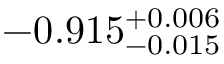Convert formula to latex. <formula><loc_0><loc_0><loc_500><loc_500>- 0 . 9 1 5 _ { - 0 . 0 1 5 } ^ { + 0 . 0 0 6 }</formula> 